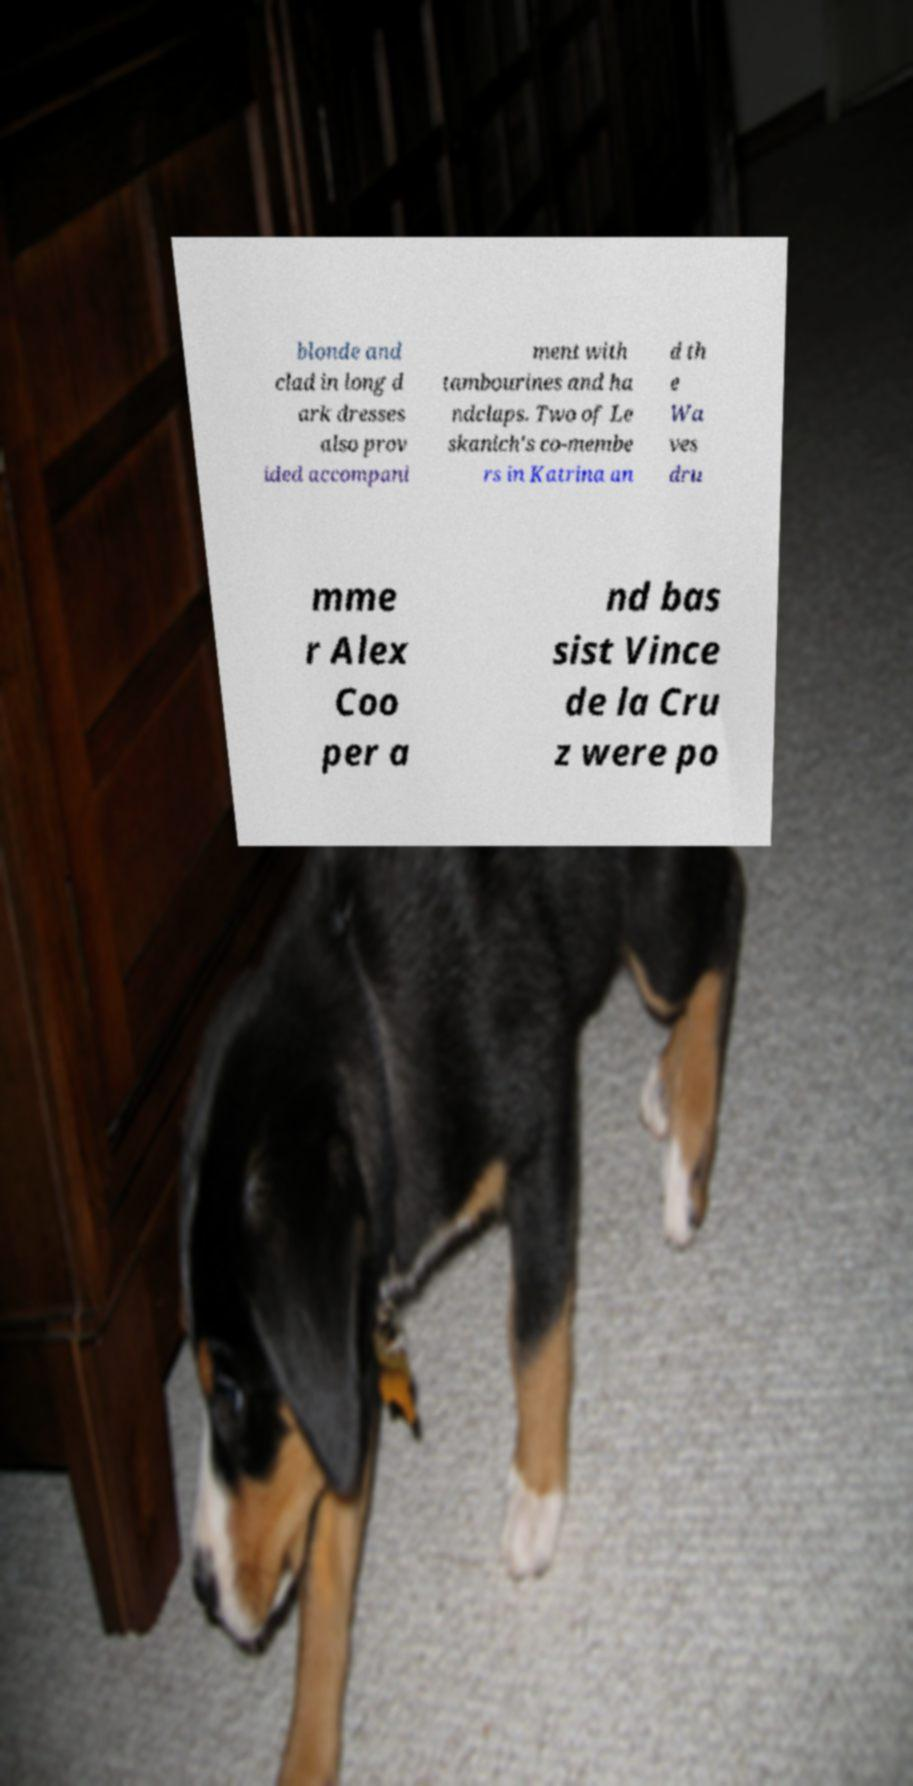Could you extract and type out the text from this image? blonde and clad in long d ark dresses also prov ided accompani ment with tambourines and ha ndclaps. Two of Le skanich's co-membe rs in Katrina an d th e Wa ves dru mme r Alex Coo per a nd bas sist Vince de la Cru z were po 